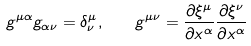<formula> <loc_0><loc_0><loc_500><loc_500>g ^ { \mu \alpha } g _ { \alpha \nu } = \delta ^ { \mu } _ { \nu } , \quad g ^ { \mu \nu } = \frac { \partial \xi ^ { \mu } } { \partial x ^ { \alpha } } \frac { \partial \xi ^ { \nu } } { \partial x ^ { \alpha } }</formula> 